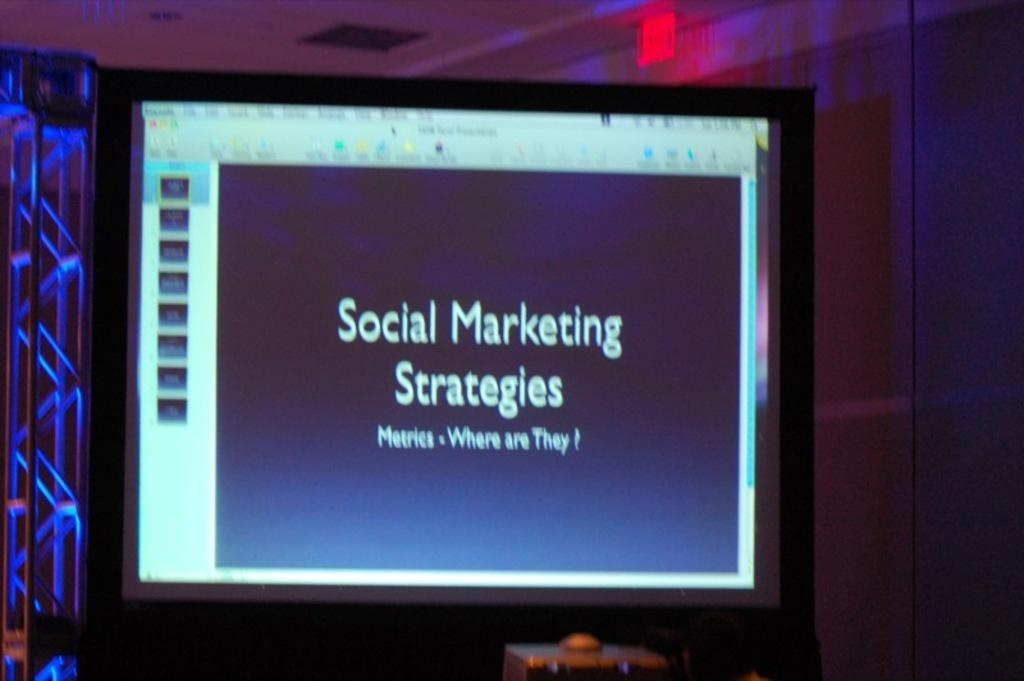<image>
Render a clear and concise summary of the photo. A screen with Social Marketing Strategies on a slide. 